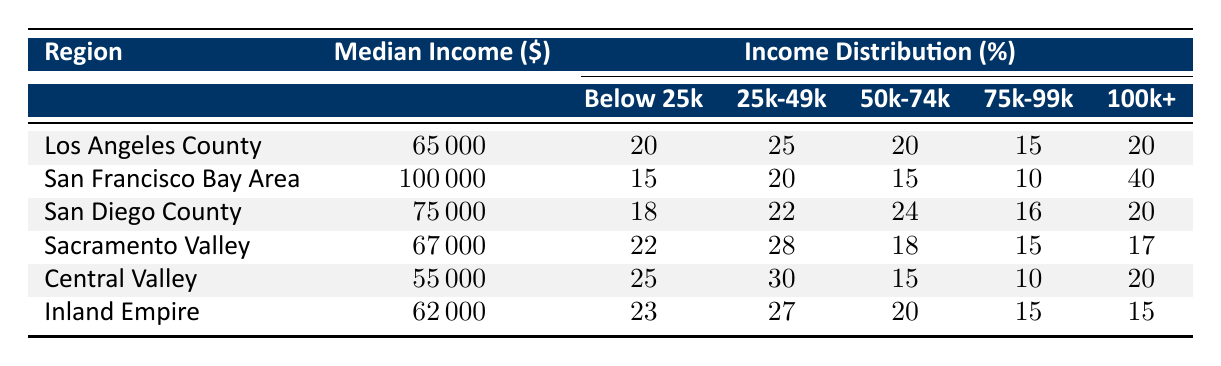What is the median income of San Francisco Bay Area? The table specifies that San Francisco Bay Area has a median income listed under the "Median Income" column, which is \$100,000.
Answer: 100000 Which region has the highest percentage of households earning below 25k? By comparing the percentages listed under "Below 25k" for each region, Central Valley has the highest percentage at 25%.
Answer: 25 What is the average median income of all regions listed? To find the average median income, add the median incomes of all regions: (65000 + 100000 + 75000 + 67000 + 55000 + 62000) = 372000. There are 6 regions, so the average is 372000 / 6 = 62000.
Answer: 62000 Is it true that San Diego County has a smaller percentage of households earning 100k and above compared to San Francisco Bay Area? The table shows that San Diego County has 20% of households earning 100k and above, while San Francisco Bay Area has 40%. Therefore, the statement is true.
Answer: True Which region has the largest disparity between its median income and the percentage of households earning below 25k? First, analyze the top three regions with the highest percentages of households earning below 25k: Central Valley (25%), Inland Empire (23%), and Sacramento Valley (22%). Compare these with their median incomes. The disparity calculation would be: Central Valley: 55000 - 25% = 32500; Inland Empire: 62000 - 23% = 43000; Sacramento Valley: 67000 - 22% = 48000. The largest disparity is in Central Valley: 55000 - (0.25 * 55000) = 41250.
Answer: Central Valley How many regions have a median income below 70000? Looking at the "Median Income" column, the regions with incomes below 70000 are Los Angeles County (65000), San Diego County (75000), and Central Valley (55000), totaling three regions below 70000.
Answer: 3 